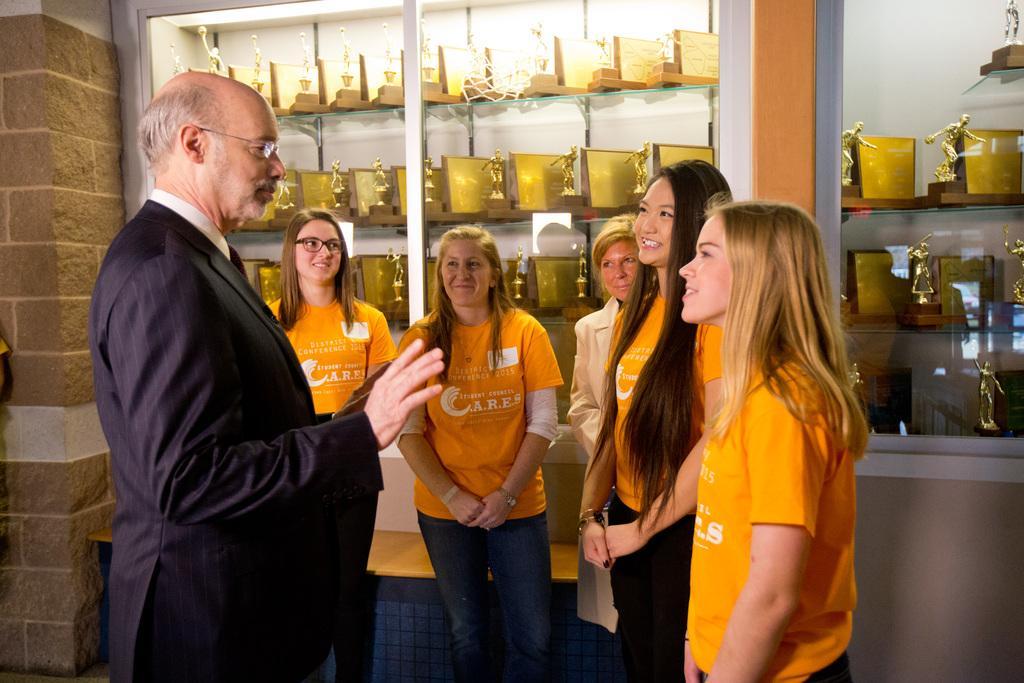Describe this image in one or two sentences. In the center of the image we can see a few people are standing and they are smiling. Among them, we can see four persons are wearing yellow t- shirts. In the background there is a wall, glass, racks, awards, banners and a few other objects. 